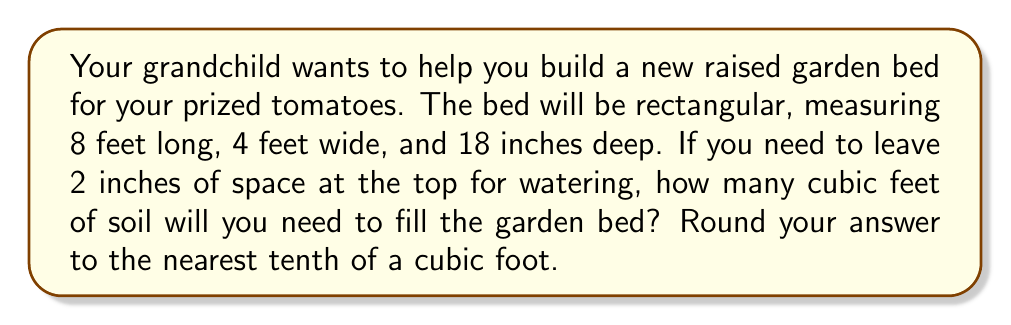Help me with this question. Let's approach this step-by-step:

1) First, we need to calculate the volume of the entire raised bed:
   $$V_{total} = length \times width \times depth$$
   $$V_{total} = 8 \text{ ft} \times 4 \text{ ft} \times 18 \text{ in}$$

2) Convert inches to feet for depth:
   $$18 \text{ in} = 18 \div 12 = 1.5 \text{ ft}$$

3) Now calculate the total volume:
   $$V_{total} = 8 \text{ ft} \times 4 \text{ ft} \times 1.5 \text{ ft} = 48 \text{ ft}^3$$

4) We need to leave 2 inches at the top, so let's calculate the volume of this space:
   $$V_{top} = 8 \text{ ft} \times 4 \text{ ft} \times 2 \text{ in}$$
   $$V_{top} = 8 \text{ ft} \times 4 \text{ ft} \times (2 \div 12) \text{ ft} = 5.33 \text{ ft}^3$$

5) The volume of soil needed is the difference:
   $$V_{soil} = V_{total} - V_{top}$$
   $$V_{soil} = 48 \text{ ft}^3 - 5.33 \text{ ft}^3 = 42.67 \text{ ft}^3$$

6) Rounding to the nearest tenth:
   $$V_{soil} \approx 42.7 \text{ ft}^3$$
Answer: 42.7 ft³ 